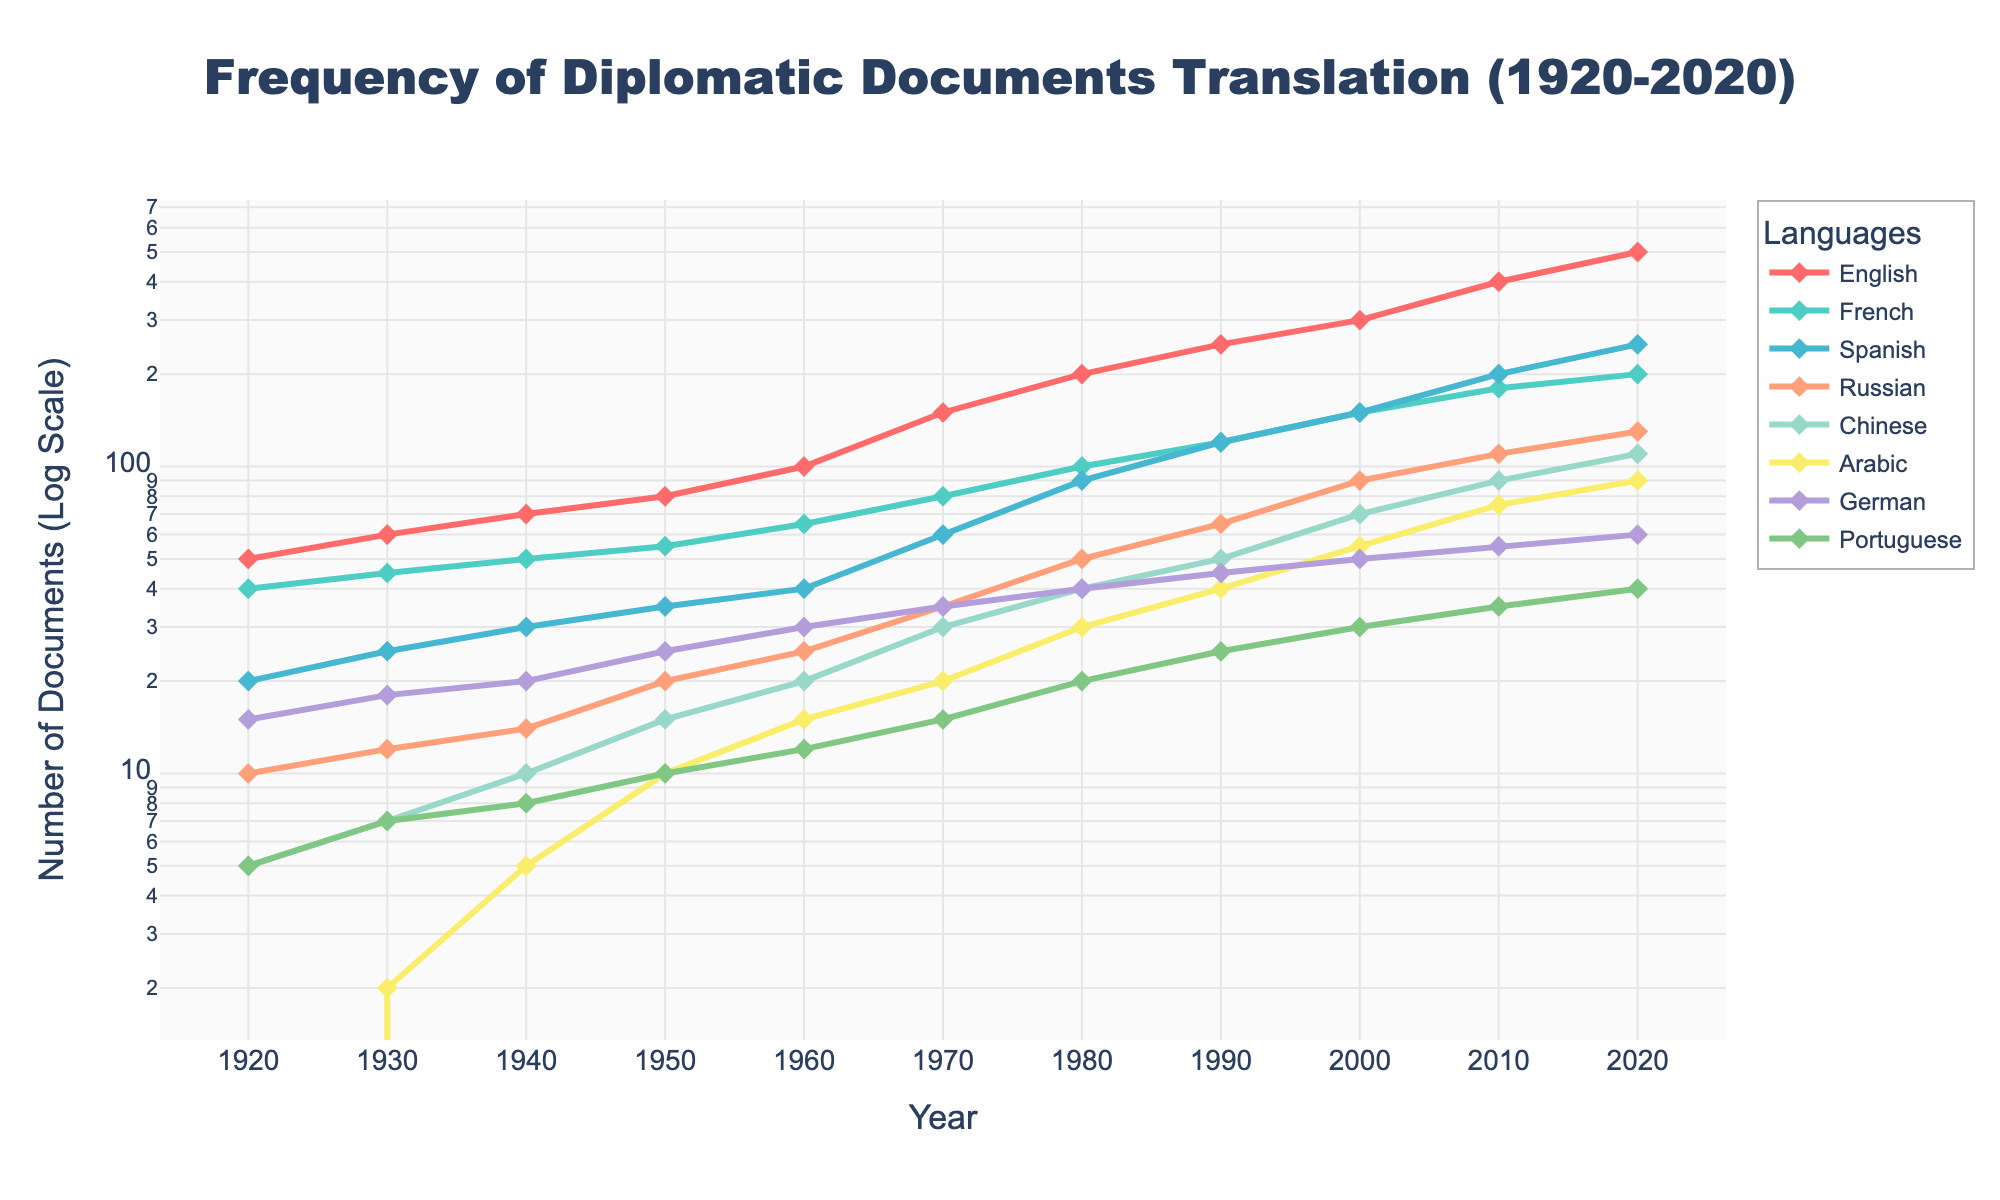What is the title of the plot? The title is located at the top of the plot and is usually in a larger font size.
Answer: Frequency of Diplomatic Documents Translation (1920-2020) Between which years does the data range? The data points start from the lowest year value to the highest year value, which are 1920 and 2020 respectively.
Answer: 1920 to 2020 Which language shows the highest frequency of document translations in 2020? The highest value for the year 2020 corresponds to the color or line representing English, which is at 500 documents.
Answer: English How many data points are plotted for the Chinese translations? Count the number of markers that represent Chinese translations across the years in the plot.
Answer: 11 In which year does Arabic show a significant increase in translations compared to the previous decade? Observe the trend for Arabic around the mid-century on the plot. There's a noticeable increase between 1940 and 1950.
Answer: 1950 What is the difference in the number of English translated documents between 2000 and 2020? Subtract the value of English translations in 2000 from 2020 (i.e., 500 - 300).
Answer: 200 Which two languages have translated documents that are closest in number in 2010? Compare the values for each language in 2010 and find the smallest difference. In 2010, French and Arabic both stand at around 75 and 90 respectively.
Answer: Arabic and Chinese Which language had the steepest increase in translations from 1980 to 1990? Calculate the slope for each language by subtracting the 1980 value from the 1990 value and identify the largest difference. Spanish shows an increase from 90 to 120.
Answer: Spanish What was the frequency of Portuguese translations in 1940? The number of Portuguese translations in 1940 is shown by the value at that year, which is 8.
Answer: 8 Which language experienced the least growth in the number of translations from 1940 to 1950? Compare the increase for each language over this period, identifying the smallest increase. Arabic went from 5 to 10, so the increase is 5.
Answer: Arabic 